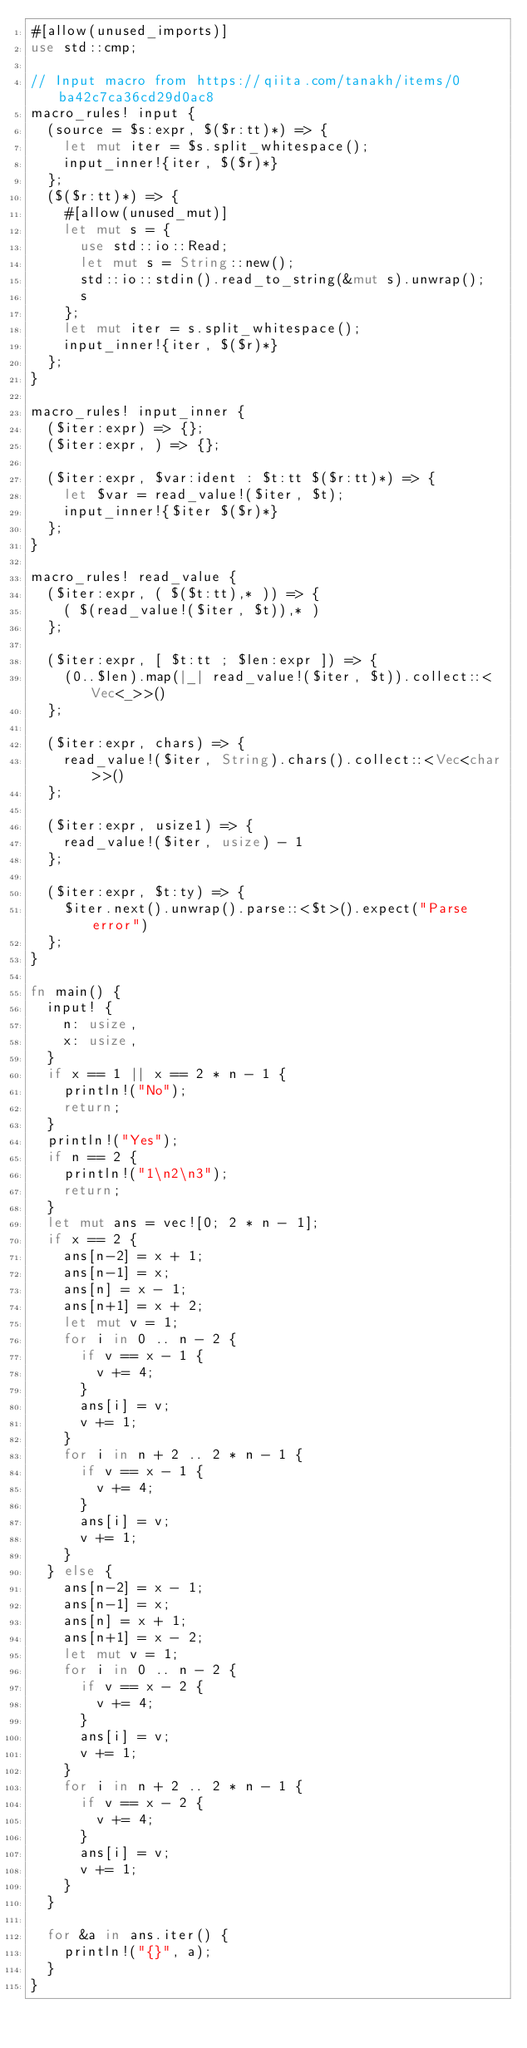<code> <loc_0><loc_0><loc_500><loc_500><_Rust_>#[allow(unused_imports)]
use std::cmp;

// Input macro from https://qiita.com/tanakh/items/0ba42c7ca36cd29d0ac8
macro_rules! input {
  (source = $s:expr, $($r:tt)*) => {
    let mut iter = $s.split_whitespace();
    input_inner!{iter, $($r)*}
  };
  ($($r:tt)*) => {
    #[allow(unused_mut)]
    let mut s = {
      use std::io::Read;
      let mut s = String::new();
      std::io::stdin().read_to_string(&mut s).unwrap();
      s
    };
    let mut iter = s.split_whitespace();
    input_inner!{iter, $($r)*}
  };
}

macro_rules! input_inner {
  ($iter:expr) => {};
  ($iter:expr, ) => {};

  ($iter:expr, $var:ident : $t:tt $($r:tt)*) => {
    let $var = read_value!($iter, $t);
    input_inner!{$iter $($r)*}
  };
}

macro_rules! read_value {
  ($iter:expr, ( $($t:tt),* )) => {
    ( $(read_value!($iter, $t)),* )
  };

  ($iter:expr, [ $t:tt ; $len:expr ]) => {
    (0..$len).map(|_| read_value!($iter, $t)).collect::<Vec<_>>()
  };

  ($iter:expr, chars) => {
    read_value!($iter, String).chars().collect::<Vec<char>>()
  };

  ($iter:expr, usize1) => {
    read_value!($iter, usize) - 1
  };

  ($iter:expr, $t:ty) => {
    $iter.next().unwrap().parse::<$t>().expect("Parse error")
  };
}

fn main() {
  input! {
    n: usize,
    x: usize,
  }
  if x == 1 || x == 2 * n - 1 {
    println!("No");
    return;
  }
  println!("Yes");
  if n == 2 {
    println!("1\n2\n3");
    return;
  }
  let mut ans = vec![0; 2 * n - 1];
  if x == 2 {
    ans[n-2] = x + 1;
    ans[n-1] = x;
    ans[n] = x - 1;
    ans[n+1] = x + 2;
    let mut v = 1;
    for i in 0 .. n - 2 {
      if v == x - 1 {
        v += 4;
      }
      ans[i] = v;
      v += 1;
    }
    for i in n + 2 .. 2 * n - 1 {
      if v == x - 1 {
        v += 4;
      }
      ans[i] = v;
      v += 1;
    }
  } else {
    ans[n-2] = x - 1;
    ans[n-1] = x;
    ans[n] = x + 1;
    ans[n+1] = x - 2;
    let mut v = 1;
    for i in 0 .. n - 2 {
      if v == x - 2 {
        v += 4;
      }
      ans[i] = v;
      v += 1;
    }
    for i in n + 2 .. 2 * n - 1 {
      if v == x - 2 {
        v += 4;
      }
      ans[i] = v;
      v += 1;
    }
  }

  for &a in ans.iter() {
    println!("{}", a);
  }
}
</code> 